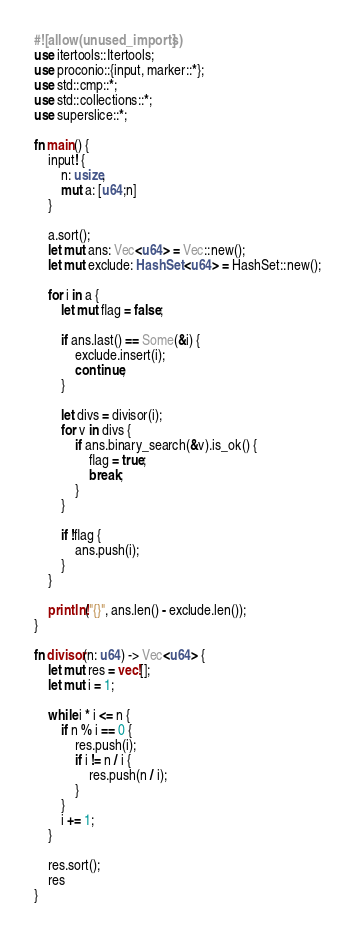<code> <loc_0><loc_0><loc_500><loc_500><_Rust_>#![allow(unused_imports)]
use itertools::Itertools;
use proconio::{input, marker::*};
use std::cmp::*;
use std::collections::*;
use superslice::*;

fn main() {
    input! {
        n: usize,
        mut a: [u64;n]
    }

    a.sort();
    let mut ans: Vec<u64> = Vec::new();
    let mut exclude: HashSet<u64> = HashSet::new();

    for i in a {
        let mut flag = false;

        if ans.last() == Some(&i) {
            exclude.insert(i);
            continue;
        }

        let divs = divisor(i);
        for v in divs {
            if ans.binary_search(&v).is_ok() {
                flag = true;
                break;
            }
        }

        if !flag {
            ans.push(i);
        }
    }

    println!("{}", ans.len() - exclude.len());
}

fn divisor(n: u64) -> Vec<u64> {
    let mut res = vec![];
    let mut i = 1;

    while i * i <= n {
        if n % i == 0 {
            res.push(i);
            if i != n / i {
                res.push(n / i);
            }
        }
        i += 1;
    }

    res.sort();
    res
}
</code> 